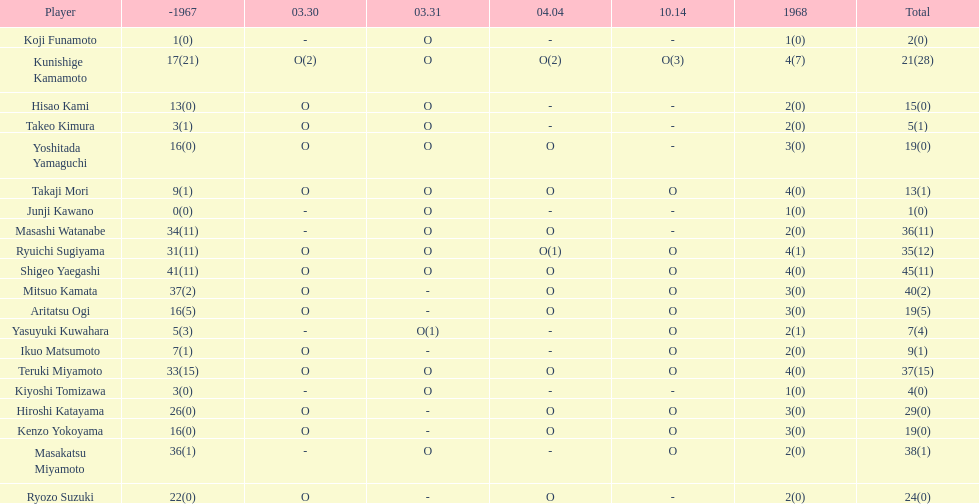Total appearances by masakatsu miyamoto? 38. 